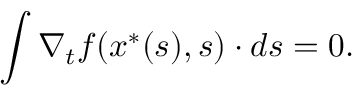Convert formula to latex. <formula><loc_0><loc_0><loc_500><loc_500>\int \nabla _ { t } f ( x ^ { \ast } ( s ) , s ) \cdot d s = 0 .</formula> 